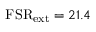<formula> <loc_0><loc_0><loc_500><loc_500>F S R _ { e x t } = 2 1 . 4</formula> 